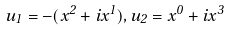<formula> <loc_0><loc_0><loc_500><loc_500>u _ { 1 } = - ( x ^ { 2 } + i x ^ { 1 } ) , u _ { 2 } = x ^ { 0 } + i x ^ { 3 }</formula> 